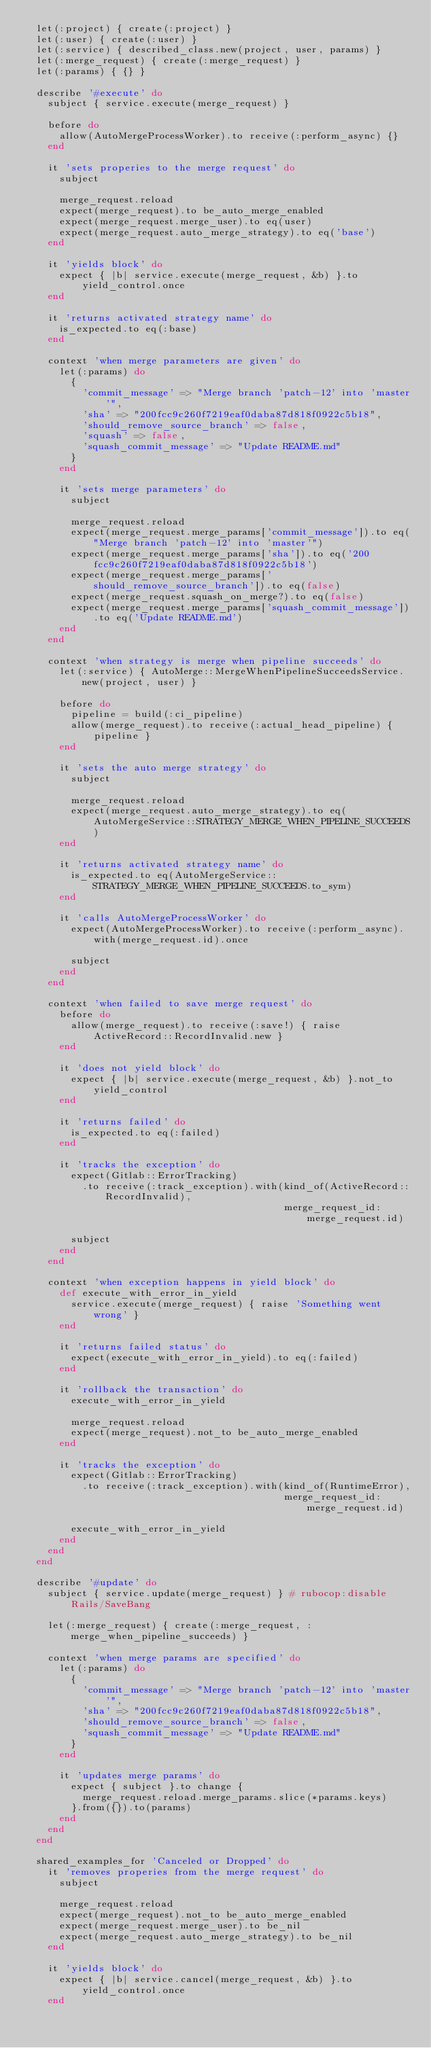Convert code to text. <code><loc_0><loc_0><loc_500><loc_500><_Ruby_>  let(:project) { create(:project) }
  let(:user) { create(:user) }
  let(:service) { described_class.new(project, user, params) }
  let(:merge_request) { create(:merge_request) }
  let(:params) { {} }

  describe '#execute' do
    subject { service.execute(merge_request) }

    before do
      allow(AutoMergeProcessWorker).to receive(:perform_async) {}
    end

    it 'sets properies to the merge request' do
      subject

      merge_request.reload
      expect(merge_request).to be_auto_merge_enabled
      expect(merge_request.merge_user).to eq(user)
      expect(merge_request.auto_merge_strategy).to eq('base')
    end

    it 'yields block' do
      expect { |b| service.execute(merge_request, &b) }.to yield_control.once
    end

    it 'returns activated strategy name' do
      is_expected.to eq(:base)
    end

    context 'when merge parameters are given' do
      let(:params) do
        {
          'commit_message' => "Merge branch 'patch-12' into 'master'",
          'sha' => "200fcc9c260f7219eaf0daba87d818f0922c5b18",
          'should_remove_source_branch' => false,
          'squash' => false,
          'squash_commit_message' => "Update README.md"
        }
      end

      it 'sets merge parameters' do
        subject

        merge_request.reload
        expect(merge_request.merge_params['commit_message']).to eq("Merge branch 'patch-12' into 'master'")
        expect(merge_request.merge_params['sha']).to eq('200fcc9c260f7219eaf0daba87d818f0922c5b18')
        expect(merge_request.merge_params['should_remove_source_branch']).to eq(false)
        expect(merge_request.squash_on_merge?).to eq(false)
        expect(merge_request.merge_params['squash_commit_message']).to eq('Update README.md')
      end
    end

    context 'when strategy is merge when pipeline succeeds' do
      let(:service) { AutoMerge::MergeWhenPipelineSucceedsService.new(project, user) }

      before do
        pipeline = build(:ci_pipeline)
        allow(merge_request).to receive(:actual_head_pipeline) { pipeline }
      end

      it 'sets the auto merge strategy' do
        subject

        merge_request.reload
        expect(merge_request.auto_merge_strategy).to eq(AutoMergeService::STRATEGY_MERGE_WHEN_PIPELINE_SUCCEEDS)
      end

      it 'returns activated strategy name' do
        is_expected.to eq(AutoMergeService::STRATEGY_MERGE_WHEN_PIPELINE_SUCCEEDS.to_sym)
      end

      it 'calls AutoMergeProcessWorker' do
        expect(AutoMergeProcessWorker).to receive(:perform_async).with(merge_request.id).once

        subject
      end
    end

    context 'when failed to save merge request' do
      before do
        allow(merge_request).to receive(:save!) { raise ActiveRecord::RecordInvalid.new }
      end

      it 'does not yield block' do
        expect { |b| service.execute(merge_request, &b) }.not_to yield_control
      end

      it 'returns failed' do
        is_expected.to eq(:failed)
      end

      it 'tracks the exception' do
        expect(Gitlab::ErrorTracking)
          .to receive(:track_exception).with(kind_of(ActiveRecord::RecordInvalid),
                                             merge_request_id: merge_request.id)

        subject
      end
    end

    context 'when exception happens in yield block' do
      def execute_with_error_in_yield
        service.execute(merge_request) { raise 'Something went wrong' }
      end

      it 'returns failed status' do
        expect(execute_with_error_in_yield).to eq(:failed)
      end

      it 'rollback the transaction' do
        execute_with_error_in_yield

        merge_request.reload
        expect(merge_request).not_to be_auto_merge_enabled
      end

      it 'tracks the exception' do
        expect(Gitlab::ErrorTracking)
          .to receive(:track_exception).with(kind_of(RuntimeError),
                                             merge_request_id: merge_request.id)

        execute_with_error_in_yield
      end
    end
  end

  describe '#update' do
    subject { service.update(merge_request) } # rubocop:disable Rails/SaveBang

    let(:merge_request) { create(:merge_request, :merge_when_pipeline_succeeds) }

    context 'when merge params are specified' do
      let(:params) do
        {
          'commit_message' => "Merge branch 'patch-12' into 'master'",
          'sha' => "200fcc9c260f7219eaf0daba87d818f0922c5b18",
          'should_remove_source_branch' => false,
          'squash_commit_message' => "Update README.md"
        }
      end

      it 'updates merge params' do
        expect { subject }.to change {
          merge_request.reload.merge_params.slice(*params.keys)
        }.from({}).to(params)
      end
    end
  end

  shared_examples_for 'Canceled or Dropped' do
    it 'removes properies from the merge request' do
      subject

      merge_request.reload
      expect(merge_request).not_to be_auto_merge_enabled
      expect(merge_request.merge_user).to be_nil
      expect(merge_request.auto_merge_strategy).to be_nil
    end

    it 'yields block' do
      expect { |b| service.cancel(merge_request, &b) }.to yield_control.once
    end
</code> 